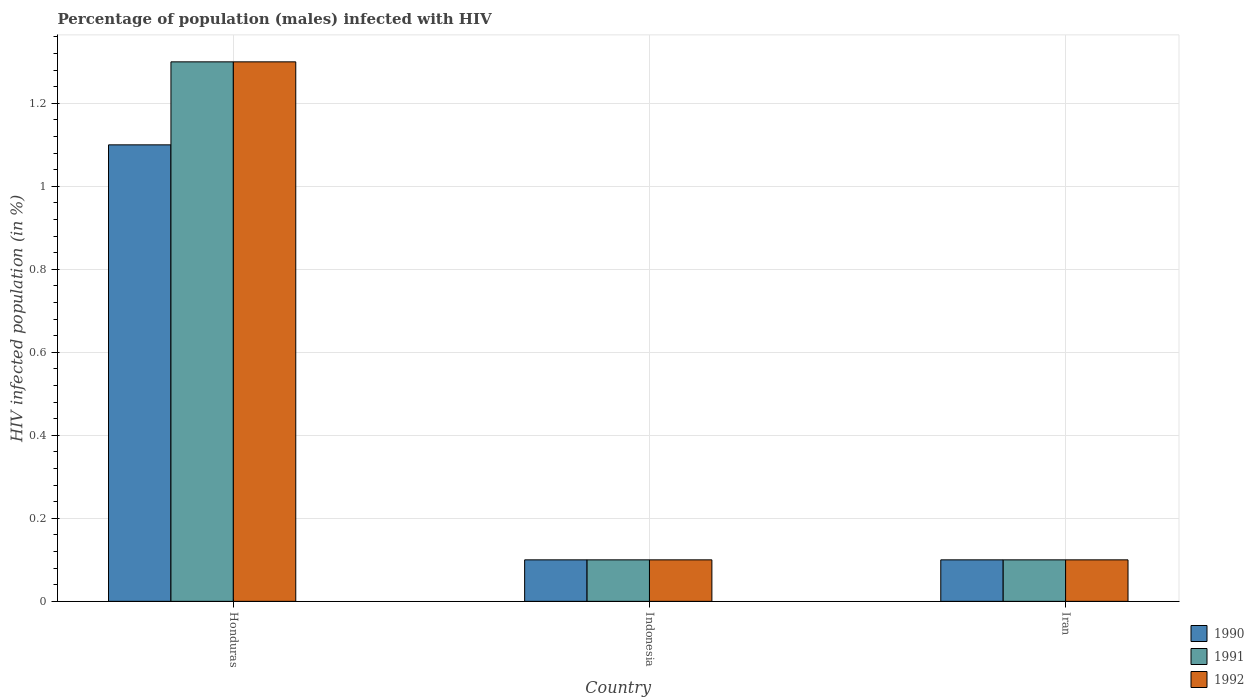How many different coloured bars are there?
Your answer should be very brief. 3. Are the number of bars on each tick of the X-axis equal?
Make the answer very short. Yes. What is the label of the 1st group of bars from the left?
Your answer should be compact. Honduras. What is the percentage of HIV infected male population in 1992 in Honduras?
Your answer should be very brief. 1.3. Across all countries, what is the maximum percentage of HIV infected male population in 1991?
Your answer should be very brief. 1.3. Across all countries, what is the minimum percentage of HIV infected male population in 1991?
Provide a short and direct response. 0.1. In which country was the percentage of HIV infected male population in 1990 maximum?
Provide a succinct answer. Honduras. In which country was the percentage of HIV infected male population in 1991 minimum?
Offer a terse response. Indonesia. What is the total percentage of HIV infected male population in 1990 in the graph?
Your response must be concise. 1.3. What is the difference between the percentage of HIV infected male population in 1992 in Honduras and that in Indonesia?
Your answer should be very brief. 1.2. What is the difference between the percentage of HIV infected male population in 1992 in Indonesia and the percentage of HIV infected male population in 1991 in Iran?
Keep it short and to the point. 0. What is the average percentage of HIV infected male population in 1991 per country?
Make the answer very short. 0.5. Is the percentage of HIV infected male population in 1990 in Honduras less than that in Iran?
Provide a short and direct response. No. What is the difference between the highest and the second highest percentage of HIV infected male population in 1992?
Make the answer very short. -1.2. Is the sum of the percentage of HIV infected male population in 1992 in Indonesia and Iran greater than the maximum percentage of HIV infected male population in 1991 across all countries?
Your answer should be very brief. No. What does the 1st bar from the right in Iran represents?
Provide a succinct answer. 1992. Is it the case that in every country, the sum of the percentage of HIV infected male population in 1991 and percentage of HIV infected male population in 1992 is greater than the percentage of HIV infected male population in 1990?
Keep it short and to the point. Yes. How many countries are there in the graph?
Provide a succinct answer. 3. What is the difference between two consecutive major ticks on the Y-axis?
Make the answer very short. 0.2. Does the graph contain any zero values?
Your answer should be very brief. No. How many legend labels are there?
Your response must be concise. 3. How are the legend labels stacked?
Keep it short and to the point. Vertical. What is the title of the graph?
Offer a terse response. Percentage of population (males) infected with HIV. Does "1962" appear as one of the legend labels in the graph?
Offer a terse response. No. What is the label or title of the X-axis?
Give a very brief answer. Country. What is the label or title of the Y-axis?
Provide a succinct answer. HIV infected population (in %). What is the HIV infected population (in %) of 1991 in Honduras?
Offer a very short reply. 1.3. What is the HIV infected population (in %) of 1992 in Honduras?
Your answer should be compact. 1.3. What is the HIV infected population (in %) in 1990 in Indonesia?
Offer a terse response. 0.1. What is the HIV infected population (in %) in 1992 in Indonesia?
Make the answer very short. 0.1. What is the HIV infected population (in %) in 1991 in Iran?
Offer a terse response. 0.1. Across all countries, what is the maximum HIV infected population (in %) of 1990?
Ensure brevity in your answer.  1.1. Across all countries, what is the maximum HIV infected population (in %) of 1992?
Your answer should be very brief. 1.3. Across all countries, what is the minimum HIV infected population (in %) in 1990?
Offer a terse response. 0.1. Across all countries, what is the minimum HIV infected population (in %) in 1992?
Ensure brevity in your answer.  0.1. What is the total HIV infected population (in %) in 1990 in the graph?
Ensure brevity in your answer.  1.3. What is the difference between the HIV infected population (in %) in 1990 in Honduras and that in Indonesia?
Give a very brief answer. 1. What is the difference between the HIV infected population (in %) of 1991 in Honduras and that in Indonesia?
Ensure brevity in your answer.  1.2. What is the difference between the HIV infected population (in %) in 1992 in Honduras and that in Indonesia?
Offer a very short reply. 1.2. What is the difference between the HIV infected population (in %) in 1990 in Honduras and that in Iran?
Provide a succinct answer. 1. What is the difference between the HIV infected population (in %) in 1992 in Indonesia and that in Iran?
Give a very brief answer. 0. What is the difference between the HIV infected population (in %) in 1990 in Honduras and the HIV infected population (in %) in 1992 in Indonesia?
Offer a terse response. 1. What is the difference between the HIV infected population (in %) of 1991 in Honduras and the HIV infected population (in %) of 1992 in Iran?
Your response must be concise. 1.2. What is the difference between the HIV infected population (in %) of 1990 in Indonesia and the HIV infected population (in %) of 1991 in Iran?
Your answer should be very brief. 0. What is the difference between the HIV infected population (in %) of 1991 in Indonesia and the HIV infected population (in %) of 1992 in Iran?
Make the answer very short. 0. What is the average HIV infected population (in %) in 1990 per country?
Offer a very short reply. 0.43. What is the average HIV infected population (in %) in 1991 per country?
Offer a very short reply. 0.5. What is the average HIV infected population (in %) of 1992 per country?
Your response must be concise. 0.5. What is the difference between the HIV infected population (in %) of 1990 and HIV infected population (in %) of 1991 in Honduras?
Ensure brevity in your answer.  -0.2. What is the difference between the HIV infected population (in %) of 1990 and HIV infected population (in %) of 1991 in Indonesia?
Give a very brief answer. 0. What is the difference between the HIV infected population (in %) in 1990 and HIV infected population (in %) in 1992 in Indonesia?
Your answer should be compact. 0. What is the difference between the HIV infected population (in %) in 1991 and HIV infected population (in %) in 1992 in Indonesia?
Offer a very short reply. 0. What is the difference between the HIV infected population (in %) in 1990 and HIV infected population (in %) in 1992 in Iran?
Your answer should be compact. 0. What is the difference between the HIV infected population (in %) in 1991 and HIV infected population (in %) in 1992 in Iran?
Your answer should be very brief. 0. What is the ratio of the HIV infected population (in %) in 1990 in Honduras to that in Indonesia?
Ensure brevity in your answer.  11. What is the ratio of the HIV infected population (in %) in 1991 in Indonesia to that in Iran?
Offer a very short reply. 1. What is the ratio of the HIV infected population (in %) in 1992 in Indonesia to that in Iran?
Provide a succinct answer. 1. What is the difference between the highest and the second highest HIV infected population (in %) in 1990?
Your answer should be compact. 1. What is the difference between the highest and the second highest HIV infected population (in %) of 1991?
Your answer should be very brief. 1.2. What is the difference between the highest and the second highest HIV infected population (in %) of 1992?
Your answer should be very brief. 1.2. What is the difference between the highest and the lowest HIV infected population (in %) in 1990?
Your answer should be very brief. 1. What is the difference between the highest and the lowest HIV infected population (in %) in 1992?
Offer a terse response. 1.2. 